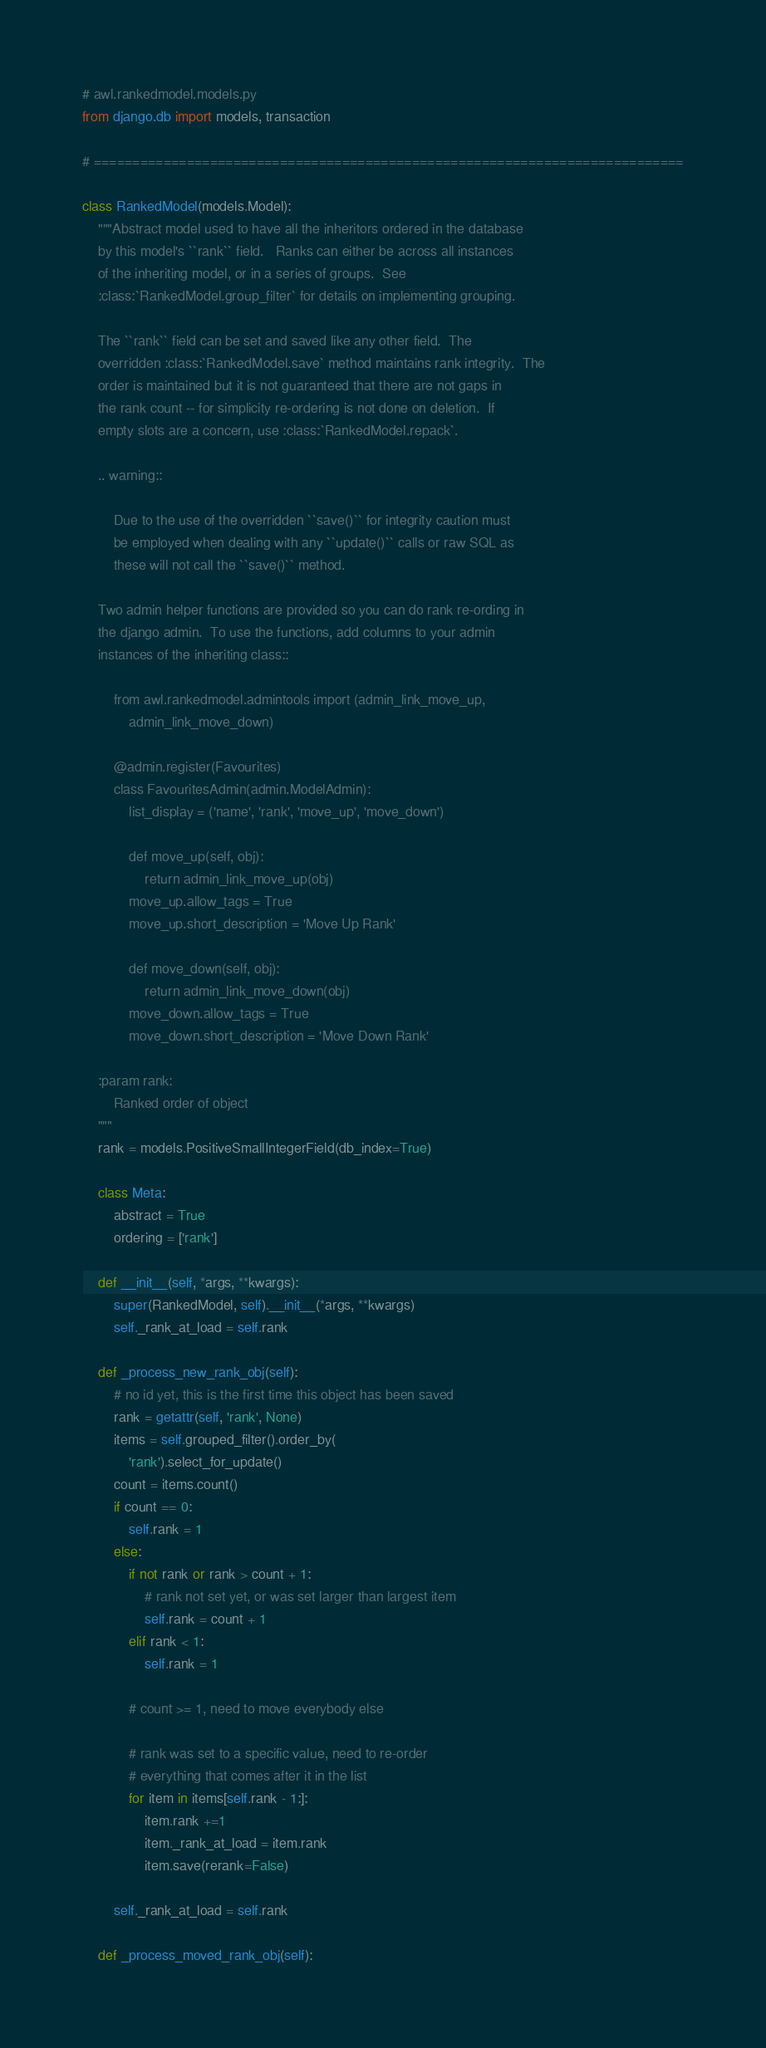Convert code to text. <code><loc_0><loc_0><loc_500><loc_500><_Python_># awl.rankedmodel.models.py
from django.db import models, transaction

# ============================================================================

class RankedModel(models.Model):
    """Abstract model used to have all the inheritors ordered in the database
    by this model's ``rank`` field.   Ranks can either be across all instances
    of the inheriting model, or in a series of groups.  See
    :class:`RankedModel.group_filter` for details on implementing grouping.

    The ``rank`` field can be set and saved like any other field.  The
    overridden :class:`RankedModel.save` method maintains rank integrity.  The
    order is maintained but it is not guaranteed that there are not gaps in
    the rank count -- for simplicity re-ordering is not done on deletion.  If
    empty slots are a concern, use :class:`RankedModel.repack`.

    .. warning::

        Due to the use of the overridden ``save()`` for integrity caution must
        be employed when dealing with any ``update()`` calls or raw SQL as
        these will not call the ``save()`` method.

    Two admin helper functions are provided so you can do rank re-ording in
    the django admin.  To use the functions, add columns to your admin
    instances of the inheriting class::

        from awl.rankedmodel.admintools import (admin_link_move_up, 
            admin_link_move_down)

        @admin.register(Favourites)
        class FavouritesAdmin(admin.ModelAdmin):
            list_display = ('name', 'rank', 'move_up', 'move_down')

            def move_up(self, obj):
                return admin_link_move_up(obj)
            move_up.allow_tags = True
            move_up.short_description = 'Move Up Rank'

            def move_down(self, obj):
                return admin_link_move_down(obj)
            move_down.allow_tags = True
            move_down.short_description = 'Move Down Rank'

    :param rank:
        Ranked order of object
    """
    rank = models.PositiveSmallIntegerField(db_index=True)

    class Meta:
        abstract = True
        ordering = ['rank']

    def __init__(self, *args, **kwargs):
        super(RankedModel, self).__init__(*args, **kwargs)
        self._rank_at_load = self.rank

    def _process_new_rank_obj(self):
        # no id yet, this is the first time this object has been saved
        rank = getattr(self, 'rank', None)
        items = self.grouped_filter().order_by(
            'rank').select_for_update()
        count = items.count()
        if count == 0:
            self.rank = 1
        else:
            if not rank or rank > count + 1:
                # rank not set yet, or was set larger than largest item
                self.rank = count + 1
            elif rank < 1:
                self.rank = 1

            # count >= 1, need to move everybody else

            # rank was set to a specific value, need to re-order
            # everything that comes after it in the list
            for item in items[self.rank - 1:]:
                item.rank +=1
                item._rank_at_load = item.rank
                item.save(rerank=False)

        self._rank_at_load = self.rank

    def _process_moved_rank_obj(self):</code> 